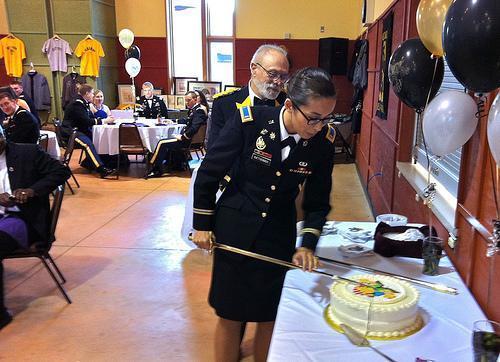How many people are standing by the cake table?
Give a very brief answer. 2. 